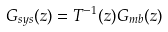Convert formula to latex. <formula><loc_0><loc_0><loc_500><loc_500>G _ { s y s } ( z ) = T ^ { - 1 } ( z ) G _ { m b } ( z )</formula> 